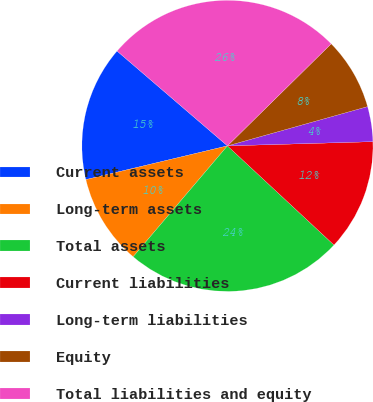<chart> <loc_0><loc_0><loc_500><loc_500><pie_chart><fcel>Current assets<fcel>Long-term assets<fcel>Total assets<fcel>Current liabilities<fcel>Long-term liabilities<fcel>Equity<fcel>Total liabilities and equity<nl><fcel>15.02%<fcel>10.06%<fcel>24.29%<fcel>12.39%<fcel>3.89%<fcel>8.02%<fcel>26.34%<nl></chart> 